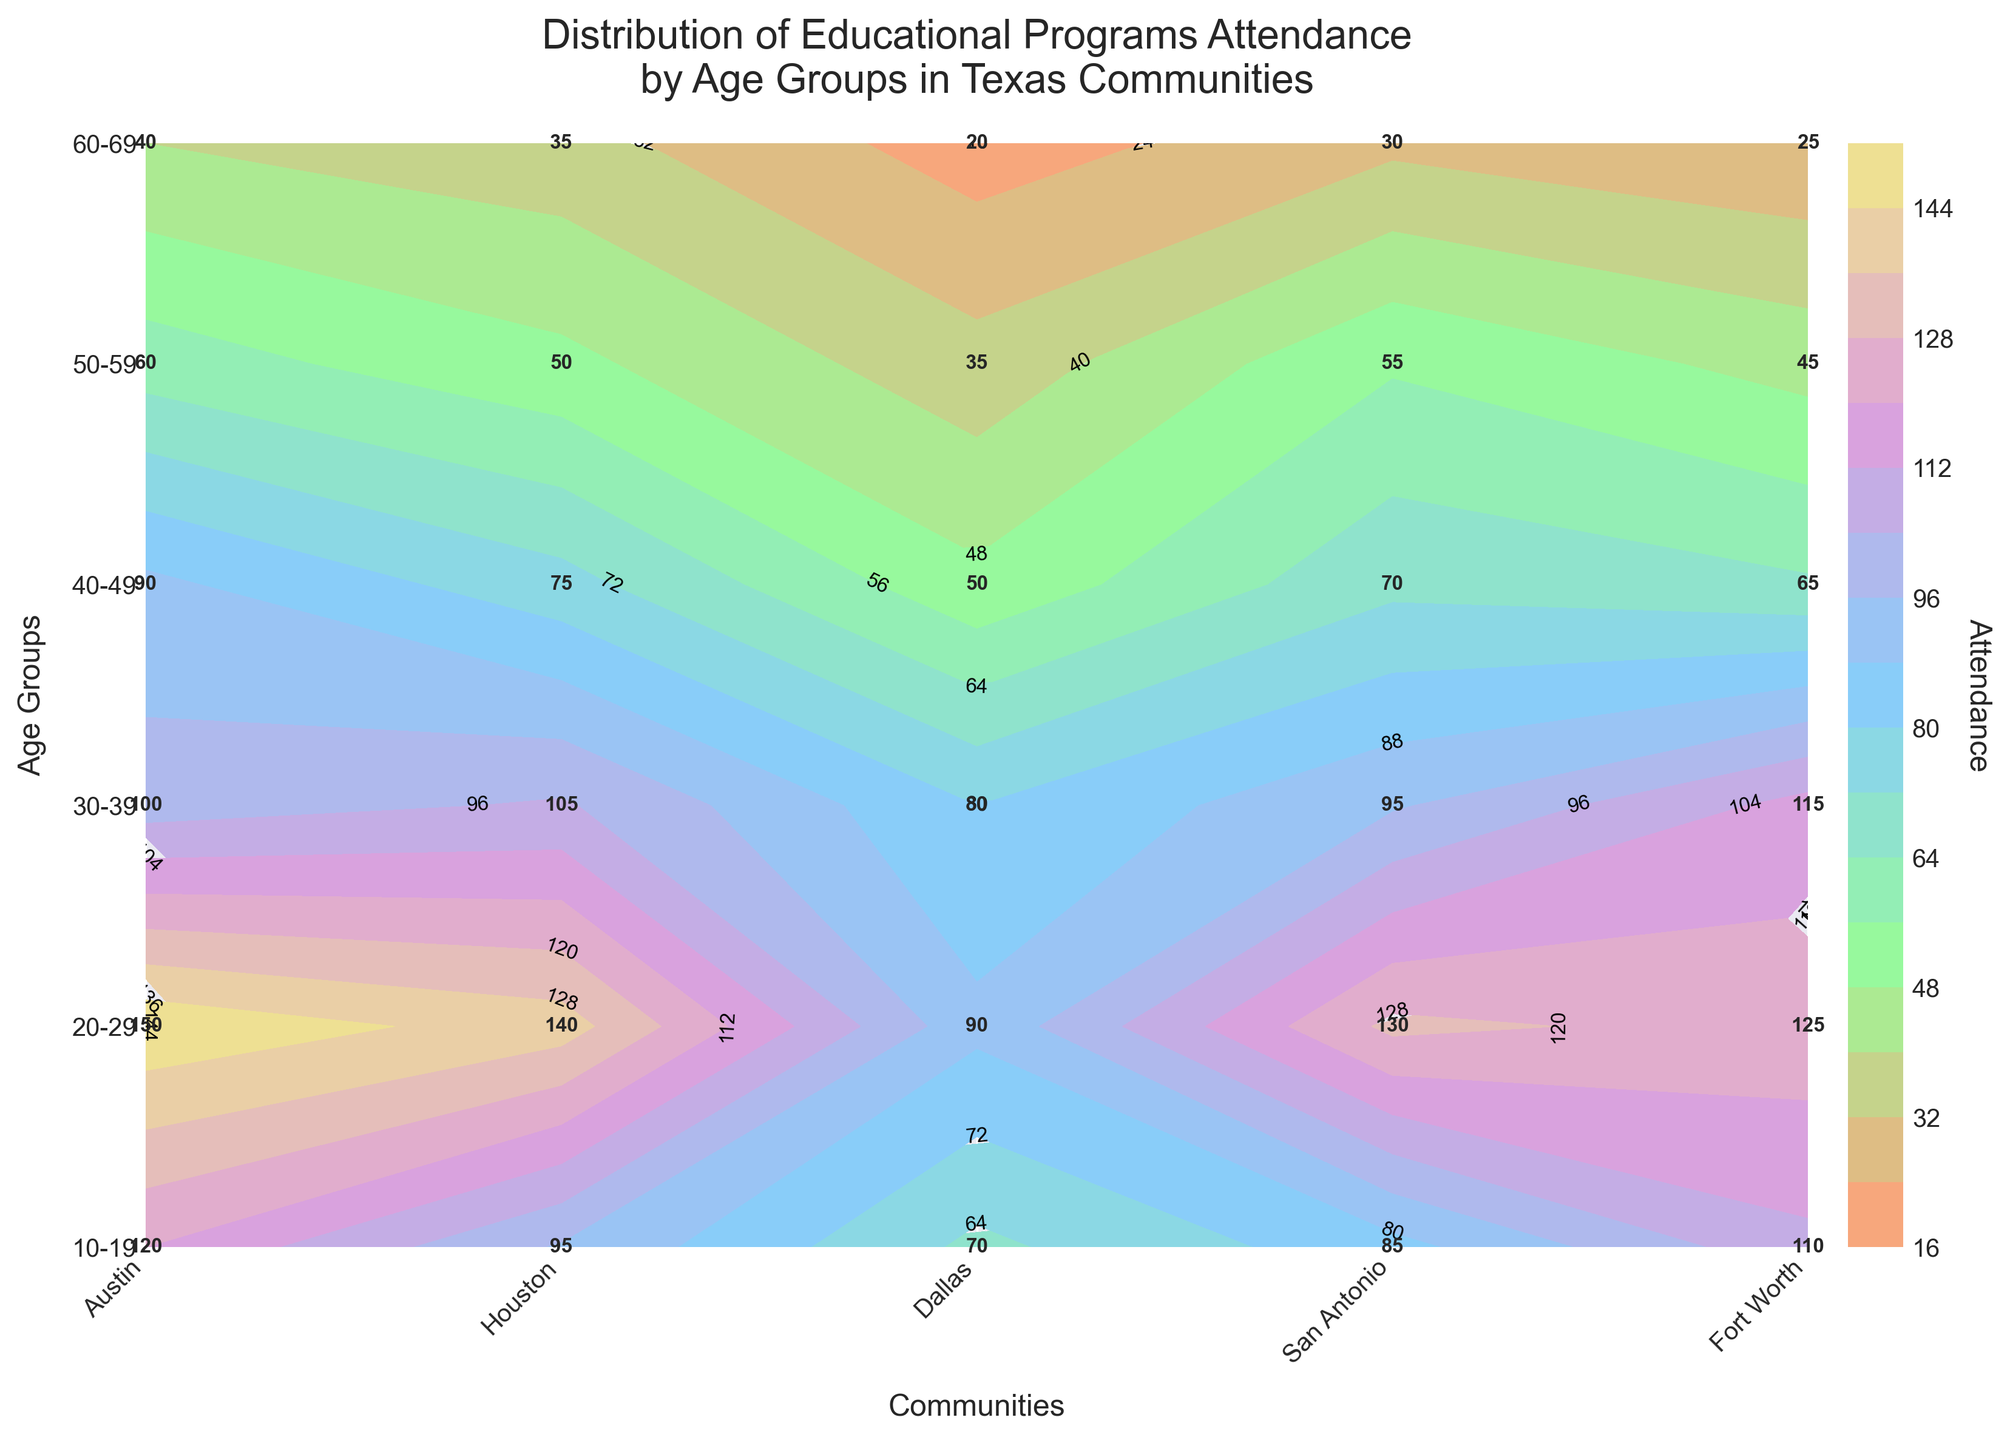What is the title of the plot? The title of the plot is located at the top and it reads 'Distribution of Educational Programs Attendance by Age Groups in Texas Communities'.
Answer: 'Distribution of Educational Programs Attendance by Age Groups in Texas Communities' Which community has the highest attendance for the age group 20-29? Look at the 20-29 age group row and scan for the highest attendance value across the communities. The highest value is 150 which corresponds to Austin.
Answer: Austin How many age groups are represented in the plot? Count the number of unique labels on the y-axis which represent age groups. There are six unique age groups listed from 10-19 to 60-69.
Answer: 6 For which age group does Houston have the lowest attendance? Review the attendance values for each age group under the Houston column. The lowest value is 30 which corresponds to the age group 60-69.
Answer: 60-69 What is the difference in attendance between the age groups of 10-19 and 60-69 in Austin? Subtract the attendance value of the age group 60-69 from that of 10-19 in Austin. The values are 120 (10-19) - 40 (60-69) = 80.
Answer: 80 Which community shows the smallest variation in attendance across all age groups? Compare the range (difference between the highest and lowest values) of attendance across all age groups for each community. The smallest range is noted in Houston, which ranges from 30 to 130.
Answer: Houston How does the attendance in Dallas for the age group 30-39 compare with that of Fort Worth for the same group? Refer to the values for the 30-39 age group in both Dallas and Fort Worth. Dallas has 105 and Fort Worth has 80. Therefore, Dallas has higher attendance.
Answer: Dallas has higher attendance What is the average attendance for San Antonio across all age groups? Calculate the average by summing the attendance values for each age group in San Antonio and dividing by the number of age groups. The sum is 110 + 125 + 115 + 65 + 45 + 25 = 485. There are 6 age groups, so 485 / 6 ≈ 80.83.
Answer: 80.83 Are there any age groups where Fort Worth has consistent attendance levels similar to another community? Fort Worth’s attendance is compared with other communities for consistency. Fort Worth shows consistent lower values across age groups, similar to the pattern in Houston.
Answer: Houston and Fort Worth show similar trends In which age group and community combination is the attendance value closest to the median attendance? Median attendance is calculated by listing all attendance values (from all age groups and communities) in order and finding the middle value. The median of 30 values is between the 15th and 16th values, both being 75 and 80 respectively. The closest value to this median is Fort Worth for the age group 40-49 with 50.
Answer: Fort Worth, 40-49 